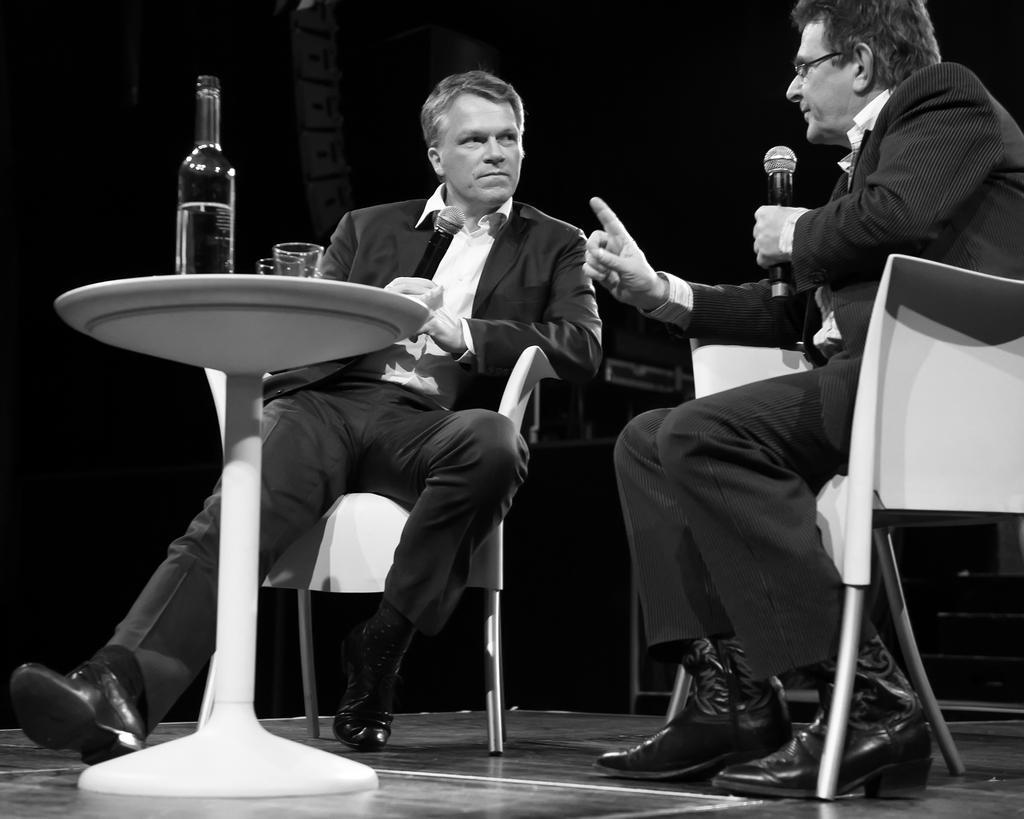Can you describe this image briefly? This Picture Describe about two men discussing with each other , Right side man is sitting on the chair is talking on the microphone and pointing his hand straight. Other person wearing black coat is listening to him , In center we can see the white small table on which one bottle and glass is seen. 